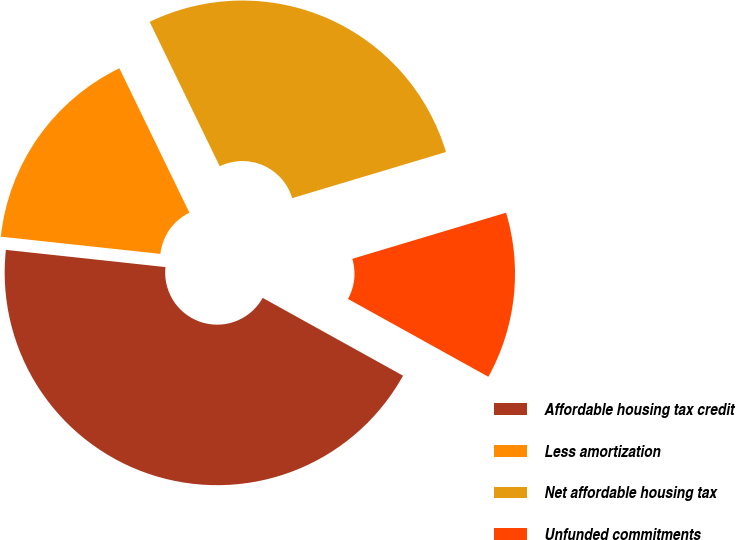<chart> <loc_0><loc_0><loc_500><loc_500><pie_chart><fcel>Affordable housing tax credit<fcel>Less amortization<fcel>Net affordable housing tax<fcel>Unfunded commitments<nl><fcel>43.65%<fcel>16.1%<fcel>27.55%<fcel>12.69%<nl></chart> 